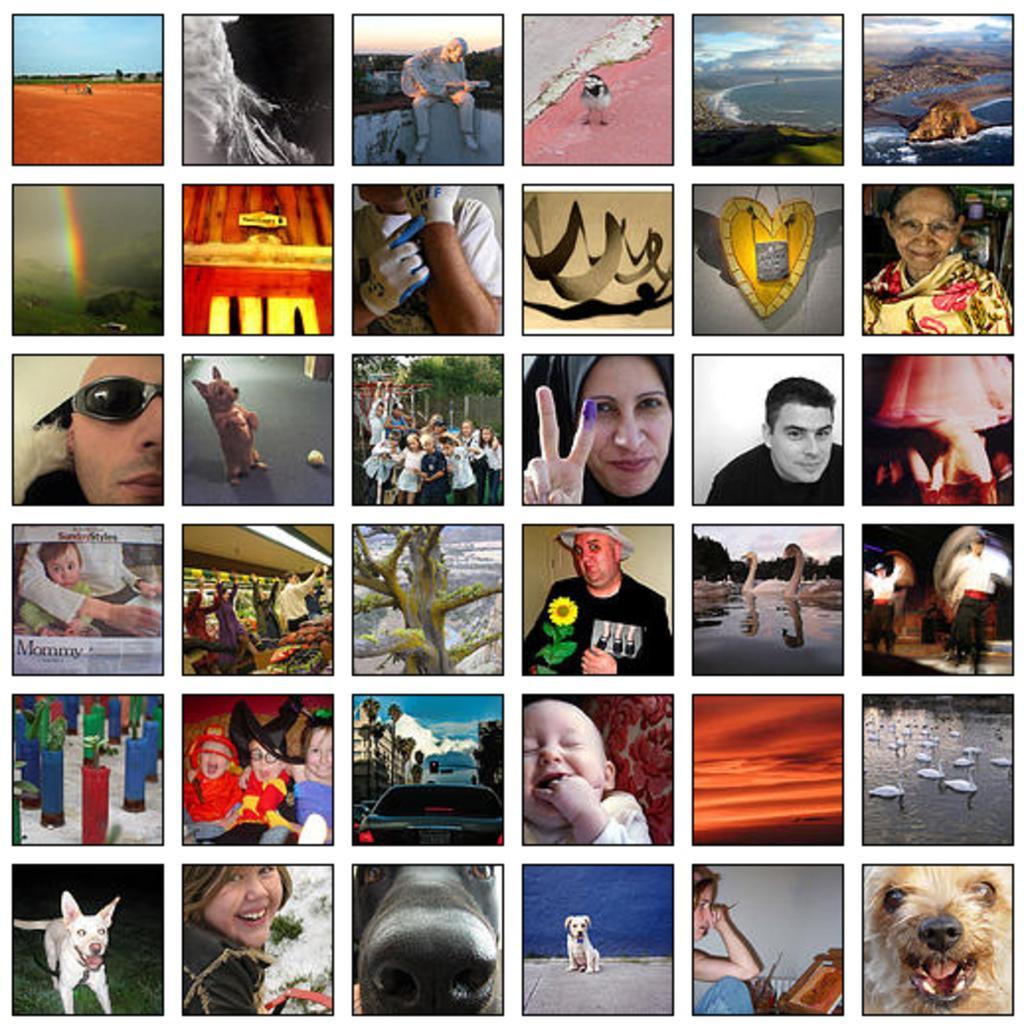How would you summarize this image in a sentence or two? This is a collage image, in this image there are different pictures. 